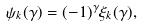Convert formula to latex. <formula><loc_0><loc_0><loc_500><loc_500>\psi _ { k } ( \gamma ) = ( - 1 ) ^ { \gamma } \xi _ { k } ( \gamma ) ,</formula> 